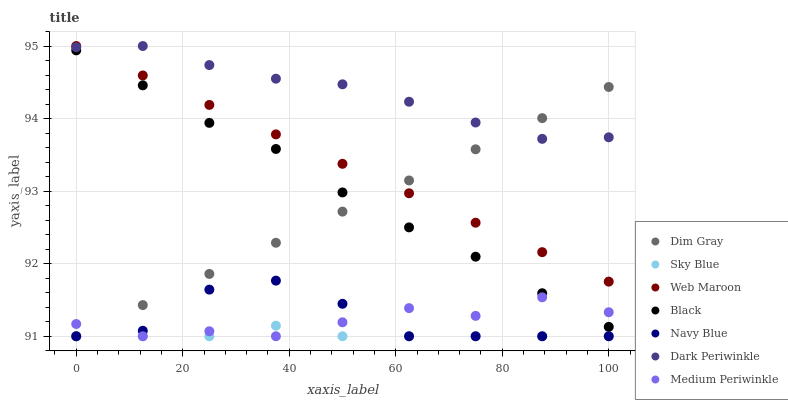Does Sky Blue have the minimum area under the curve?
Answer yes or no. Yes. Does Dark Periwinkle have the maximum area under the curve?
Answer yes or no. Yes. Does Medium Periwinkle have the minimum area under the curve?
Answer yes or no. No. Does Medium Periwinkle have the maximum area under the curve?
Answer yes or no. No. Is Web Maroon the smoothest?
Answer yes or no. Yes. Is Navy Blue the roughest?
Answer yes or no. Yes. Is Medium Periwinkle the smoothest?
Answer yes or no. No. Is Medium Periwinkle the roughest?
Answer yes or no. No. Does Dim Gray have the lowest value?
Answer yes or no. Yes. Does Web Maroon have the lowest value?
Answer yes or no. No. Does Dark Periwinkle have the highest value?
Answer yes or no. Yes. Does Medium Periwinkle have the highest value?
Answer yes or no. No. Is Navy Blue less than Black?
Answer yes or no. Yes. Is Black greater than Sky Blue?
Answer yes or no. Yes. Does Sky Blue intersect Navy Blue?
Answer yes or no. Yes. Is Sky Blue less than Navy Blue?
Answer yes or no. No. Is Sky Blue greater than Navy Blue?
Answer yes or no. No. Does Navy Blue intersect Black?
Answer yes or no. No. 